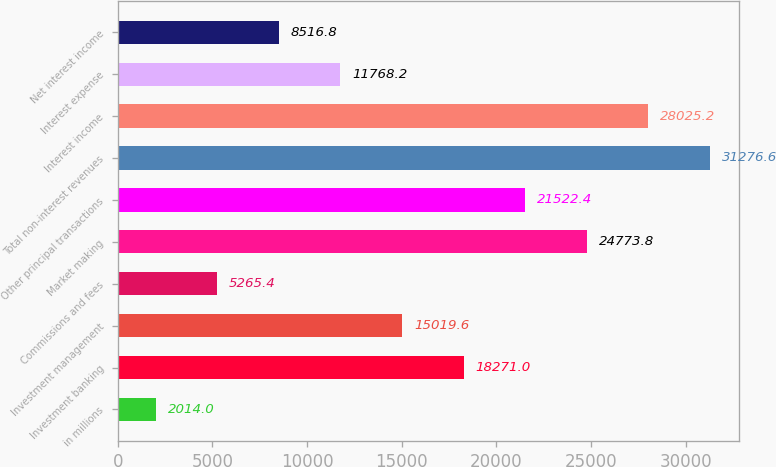Convert chart to OTSL. <chart><loc_0><loc_0><loc_500><loc_500><bar_chart><fcel>in millions<fcel>Investment banking<fcel>Investment management<fcel>Commissions and fees<fcel>Market making<fcel>Other principal transactions<fcel>Total non-interest revenues<fcel>Interest income<fcel>Interest expense<fcel>Net interest income<nl><fcel>2014<fcel>18271<fcel>15019.6<fcel>5265.4<fcel>24773.8<fcel>21522.4<fcel>31276.6<fcel>28025.2<fcel>11768.2<fcel>8516.8<nl></chart> 